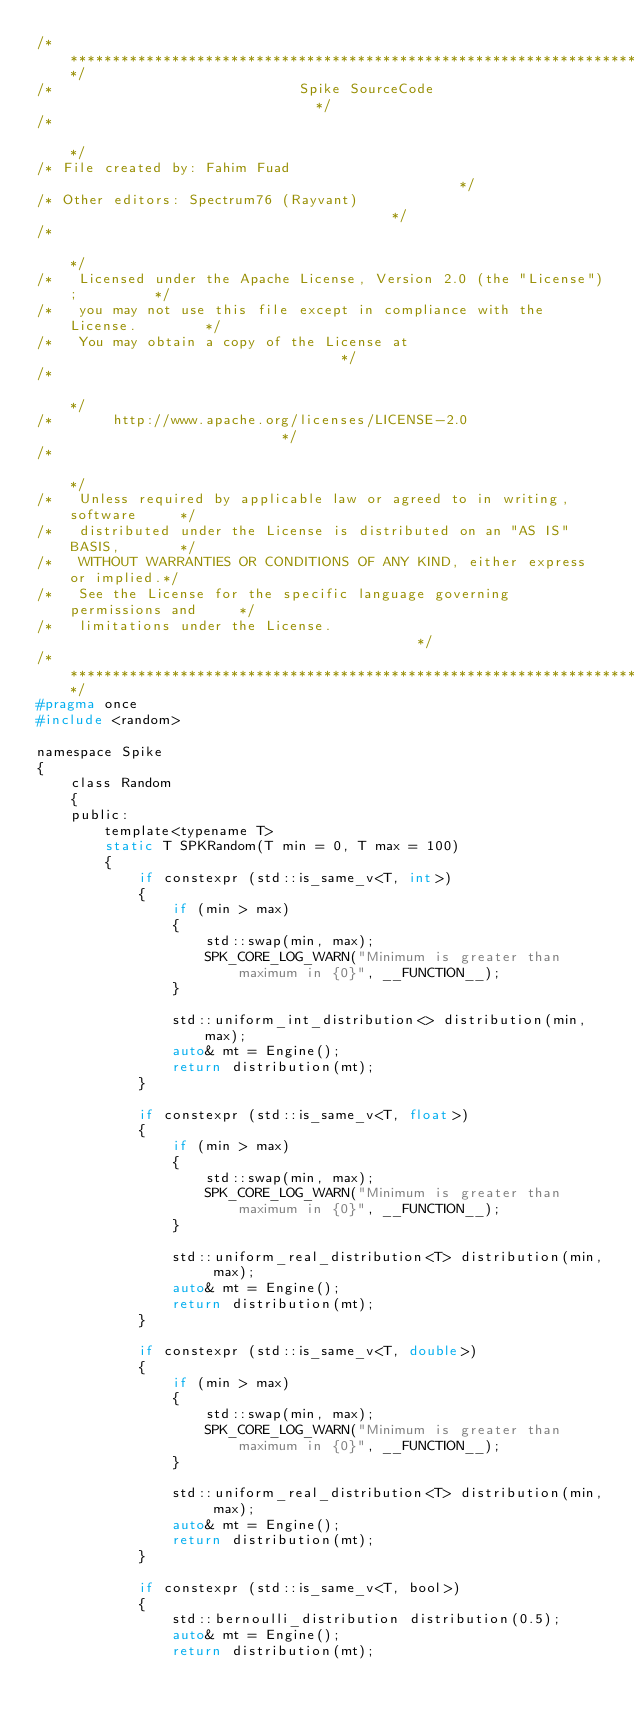<code> <loc_0><loc_0><loc_500><loc_500><_C_>/*****************************************************************************/
/*                             Spike SourceCode                              */
/*                                                                           */
/* File created by: Fahim Fuad                                               */
/* Other editors: Spectrum76 (Rayvant)                                       */
/*                                                                           */
/*   Licensed under the Apache License, Version 2.0 (the "License");         */
/*   you may not use this file except in compliance with the License.        */
/*   You may obtain a copy of the License at                                 */
/*                                                                           */
/*       http://www.apache.org/licenses/LICENSE-2.0                          */
/*                                                                           */
/*   Unless required by applicable law or agreed to in writing, software     */
/*   distributed under the License is distributed on an "AS IS" BASIS,       */
/*   WITHOUT WARRANTIES OR CONDITIONS OF ANY KIND, either express or implied.*/
/*   See the License for the specific language governing permissions and     */
/*   limitations under the License.                                          */
/*****************************************************************************/
#pragma once
#include <random>

namespace Spike
{
    class Random
    {
    public:
        template<typename T>
        static T SPKRandom(T min = 0, T max = 100)
        {
            if constexpr (std::is_same_v<T, int>)
            {
                if (min > max)
                {
                    std::swap(min, max);
                    SPK_CORE_LOG_WARN("Minimum is greater than maximum in {0}", __FUNCTION__);
                }

                std::uniform_int_distribution<> distribution(min, max);
                auto& mt = Engine();
                return distribution(mt);
            }

            if constexpr (std::is_same_v<T, float>)
            {
                if (min > max)
                {
                    std::swap(min, max);
                    SPK_CORE_LOG_WARN("Minimum is greater than maximum in {0}", __FUNCTION__);
                }

                std::uniform_real_distribution<T> distribution(min, max);
                auto& mt = Engine();
                return distribution(mt);
            }

            if constexpr (std::is_same_v<T, double>)
            {
                if (min > max)
                {
                    std::swap(min, max);
                    SPK_CORE_LOG_WARN("Minimum is greater than maximum in {0}", __FUNCTION__);
                }

                std::uniform_real_distribution<T> distribution(min, max);
                auto& mt = Engine();
                return distribution(mt);
            }

            if constexpr (std::is_same_v<T, bool>)
            {
                std::bernoulli_distribution distribution(0.5);
                auto& mt = Engine();
                return distribution(mt);</code> 